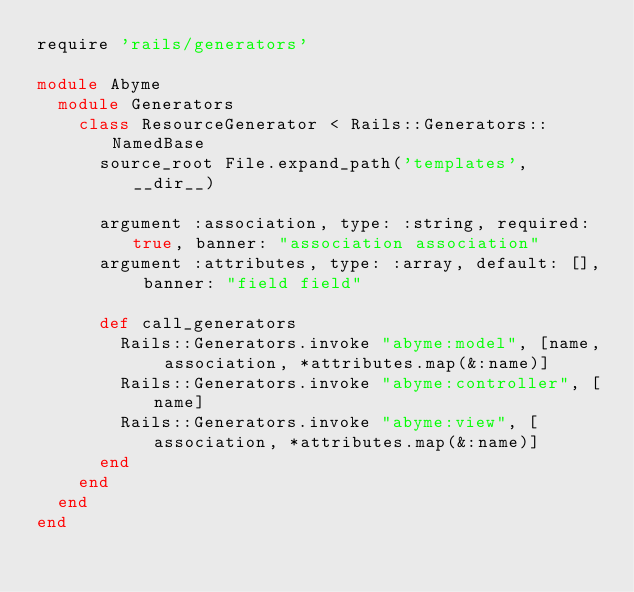<code> <loc_0><loc_0><loc_500><loc_500><_Ruby_>require 'rails/generators'

module Abyme
  module Generators
    class ResourceGenerator < Rails::Generators::NamedBase
      source_root File.expand_path('templates', __dir__)

      argument :association, type: :string, required: true, banner: "association association"
      argument :attributes, type: :array, default: [], banner: "field field"

      def call_generators
        Rails::Generators.invoke "abyme:model", [name, association, *attributes.map(&:name)]
        Rails::Generators.invoke "abyme:controller", [name]
        Rails::Generators.invoke "abyme:view", [association, *attributes.map(&:name)]
      end
    end
  end
end</code> 